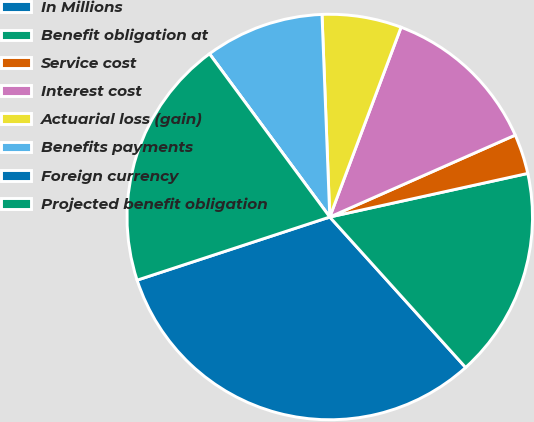Convert chart to OTSL. <chart><loc_0><loc_0><loc_500><loc_500><pie_chart><fcel>In Millions<fcel>Benefit obligation at<fcel>Service cost<fcel>Interest cost<fcel>Actuarial loss (gain)<fcel>Benefits payments<fcel>Foreign currency<fcel>Projected benefit obligation<nl><fcel>31.65%<fcel>16.76%<fcel>3.17%<fcel>12.66%<fcel>6.33%<fcel>9.5%<fcel>0.0%<fcel>19.93%<nl></chart> 